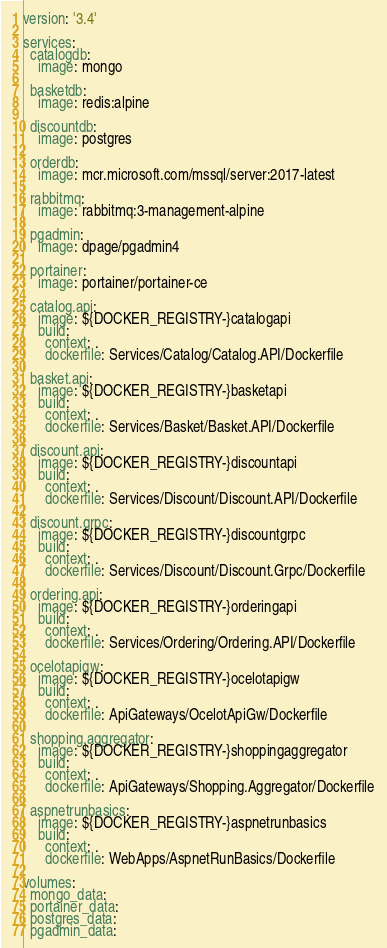Convert code to text. <code><loc_0><loc_0><loc_500><loc_500><_YAML_>version: '3.4'

services:
  catalogdb:
    image: mongo

  basketdb:
    image: redis:alpine
  
  discountdb:
    image: postgres

  orderdb:
    image: mcr.microsoft.com/mssql/server:2017-latest

  rabbitmq:
    image: rabbitmq:3-management-alpine

  pgadmin:
    image: dpage/pgadmin4
    
  portainer:
    image: portainer/portainer-ce

  catalog.api:
    image: ${DOCKER_REGISTRY-}catalogapi
    build:
      context: .
      dockerfile: Services/Catalog/Catalog.API/Dockerfile
    
  basket.api:
    image: ${DOCKER_REGISTRY-}basketapi
    build:
      context: .
      dockerfile: Services/Basket/Basket.API/Dockerfile

  discount.api:
    image: ${DOCKER_REGISTRY-}discountapi
    build:
      context: .
      dockerfile: Services/Discount/Discount.API/Dockerfile

  discount.grpc:
    image: ${DOCKER_REGISTRY-}discountgrpc
    build:
      context: .
      dockerfile: Services/Discount/Discount.Grpc/Dockerfile

  ordering.api:
    image: ${DOCKER_REGISTRY-}orderingapi
    build:
      context: .
      dockerfile: Services/Ordering/Ordering.API/Dockerfile

  ocelotapigw:
    image: ${DOCKER_REGISTRY-}ocelotapigw
    build:
      context: .
      dockerfile: ApiGateways/OcelotApiGw/Dockerfile

  shopping.aggregator:
    image: ${DOCKER_REGISTRY-}shoppingaggregator
    build:
      context: .
      dockerfile: ApiGateways/Shopping.Aggregator/Dockerfile

  aspnetrunbasics:
    image: ${DOCKER_REGISTRY-}aspnetrunbasics
    build:
      context: .
      dockerfile: WebApps/AspnetRunBasics/Dockerfile

volumes:
  mongo_data:
  portainer_data: 
  postgres_data:
  pgadmin_data:






</code> 